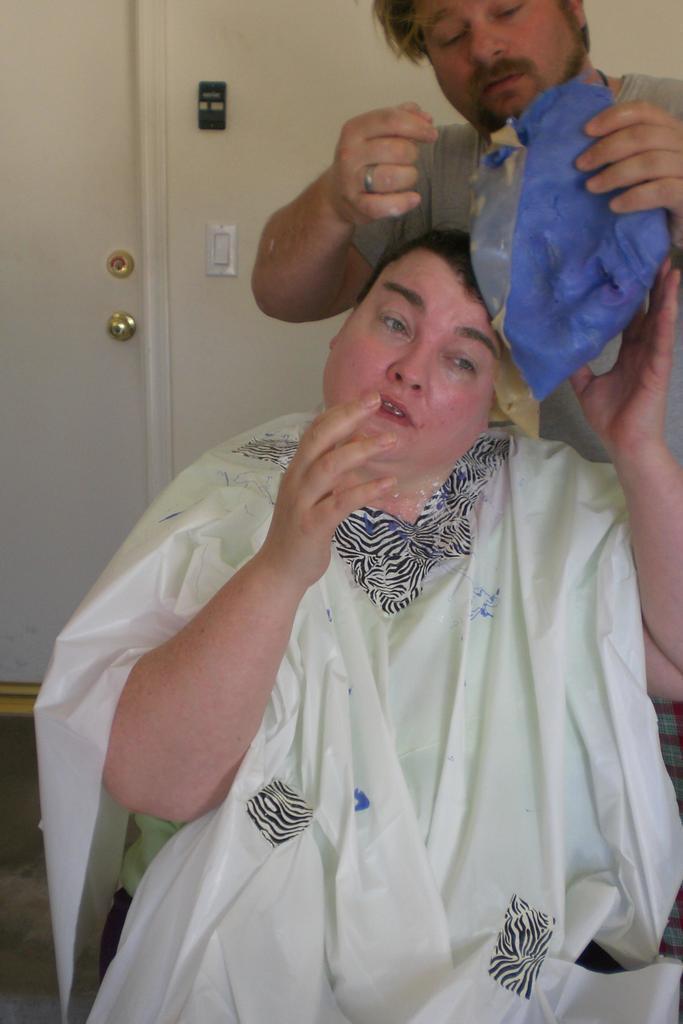Can you describe this image briefly? In this image we can see one door with knob, two objects attached to the wall in the background, it looks like a carpet on the floor, one man sitting and touching an object in the middle of the image. There is one man standing and holding an object on the right side of the image. 